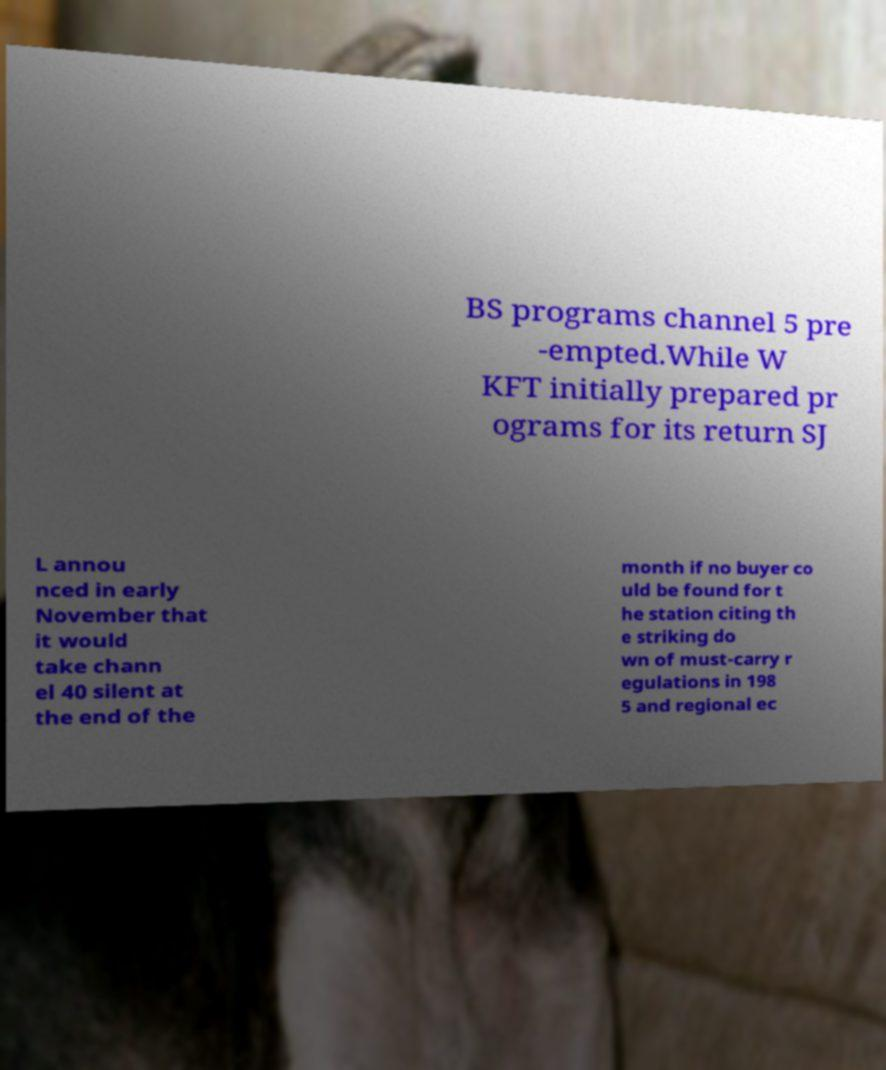Can you read and provide the text displayed in the image?This photo seems to have some interesting text. Can you extract and type it out for me? BS programs channel 5 pre -empted.While W KFT initially prepared pr ograms for its return SJ L annou nced in early November that it would take chann el 40 silent at the end of the month if no buyer co uld be found for t he station citing th e striking do wn of must-carry r egulations in 198 5 and regional ec 